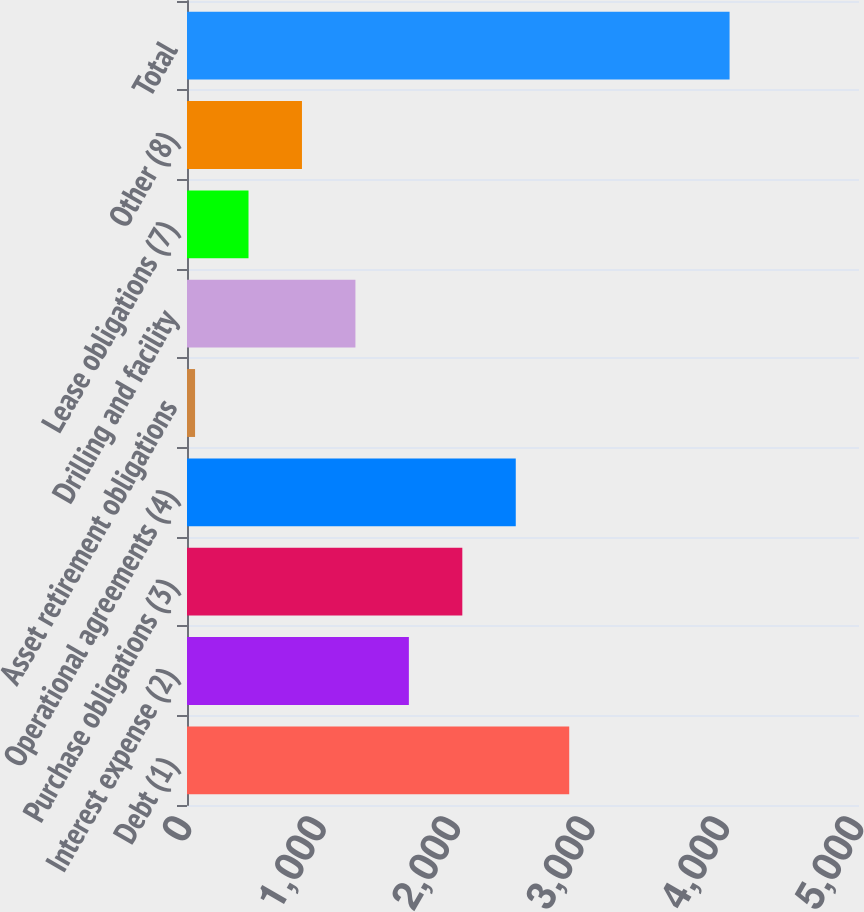Convert chart. <chart><loc_0><loc_0><loc_500><loc_500><bar_chart><fcel>Debt (1)<fcel>Interest expense (2)<fcel>Purchase obligations (3)<fcel>Operational agreements (4)<fcel>Asset retirement obligations<fcel>Drilling and facility<fcel>Lease obligations (7)<fcel>Other (8)<fcel>Total<nl><fcel>2843.9<fcel>1650.8<fcel>2048.5<fcel>2446.2<fcel>60<fcel>1253.1<fcel>457.7<fcel>855.4<fcel>4037<nl></chart> 